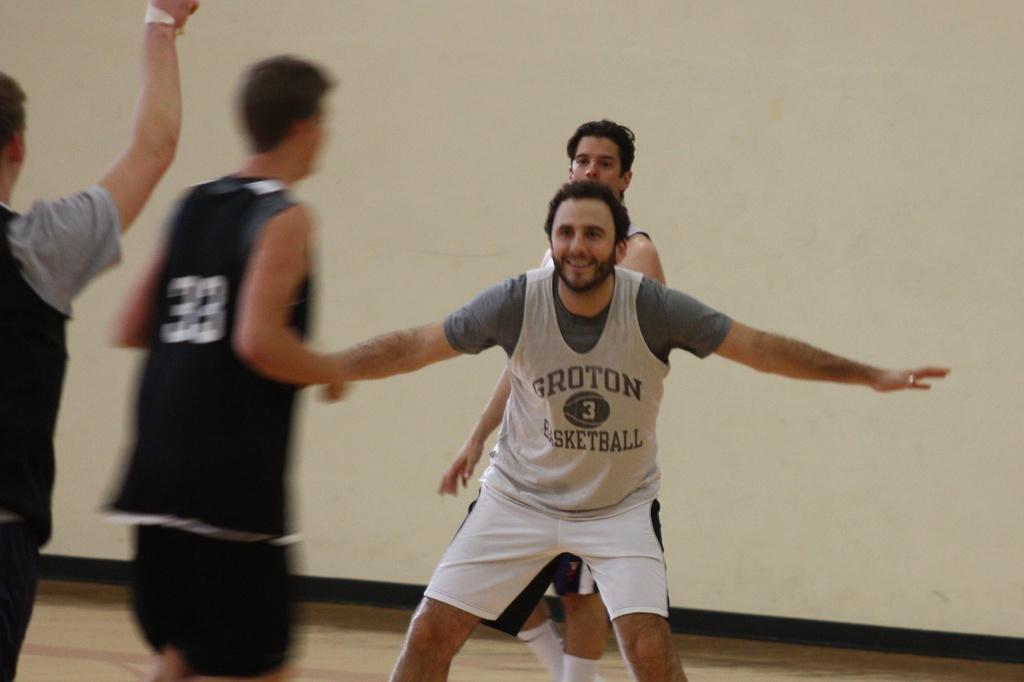What can be seen in the image? There are men standing in the image. What is visible in the background of the image? There is a wall visible in the background of the image. What type of steel is being used to construct the police hearing in the image? There is no steel, police, or hearing present in the image. 